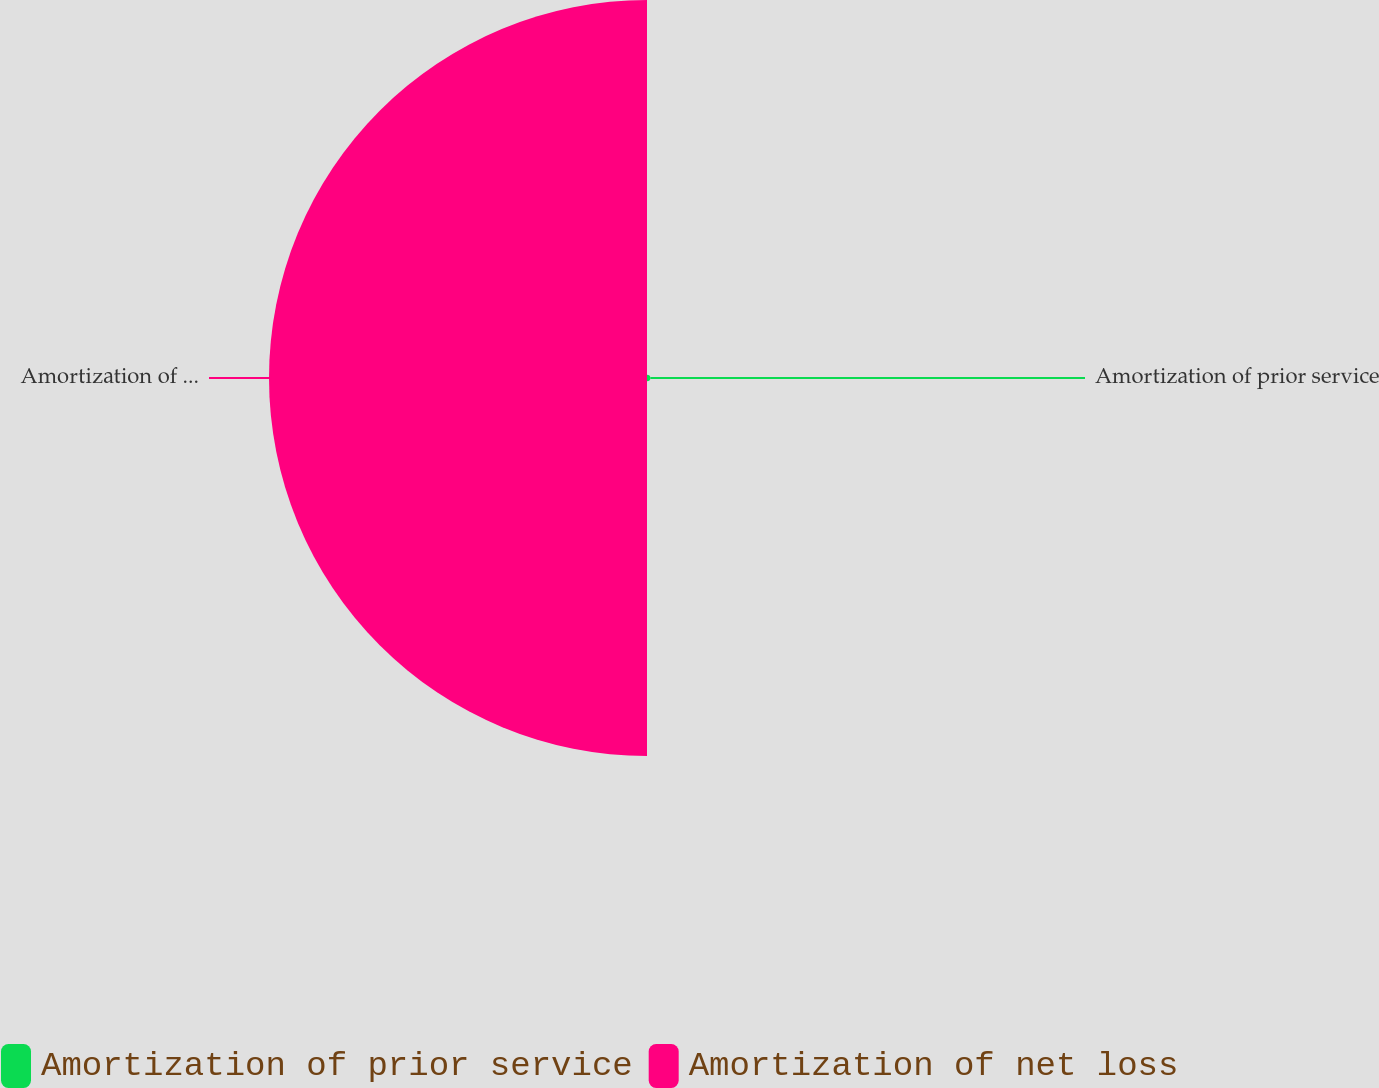<chart> <loc_0><loc_0><loc_500><loc_500><pie_chart><fcel>Amortization of prior service<fcel>Amortization of net loss<nl><fcel>0.87%<fcel>99.13%<nl></chart> 